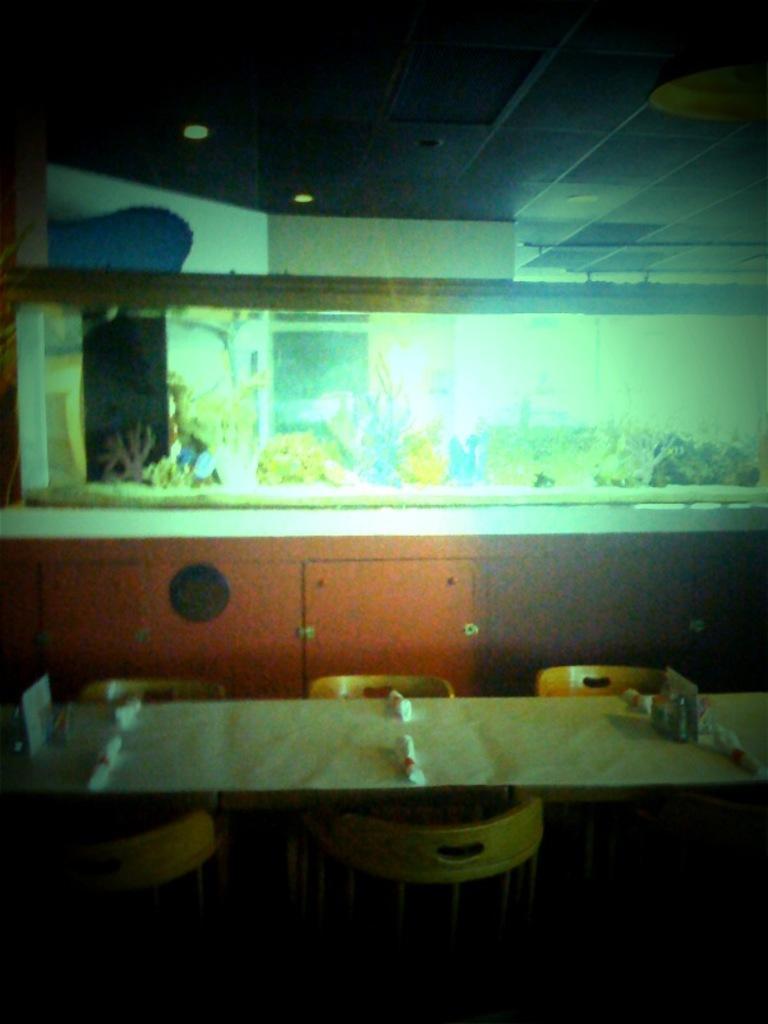Could you give a brief overview of what you see in this image? In this picture we can see the table, chairs and we can see big frame to the wall. 